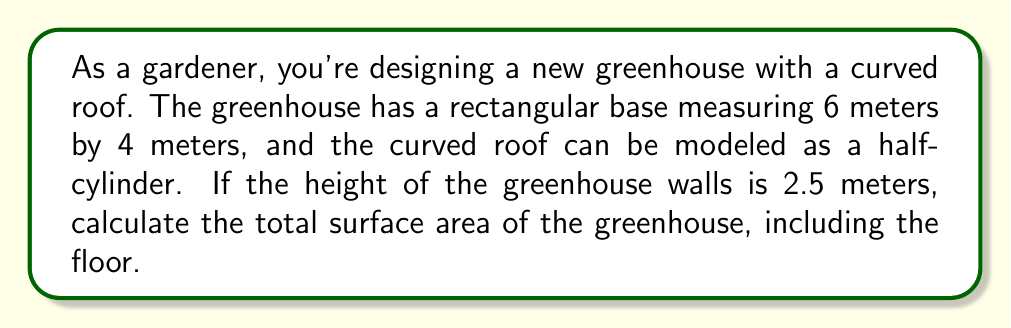Help me with this question. Let's approach this step-by-step:

1) First, we need to identify the components of the surface area:
   - Rectangular floor
   - Two rectangular end walls
   - Two rectangular side walls
   - Curved roof (half-cylinder)

2) Calculate the area of the floor:
   $A_{floor} = 6m \times 4m = 24m^2$

3) Calculate the area of the end walls (2 rectangles):
   $A_{ends} = 2 \times (4m \times 2.5m) = 20m^2$

4) Calculate the area of the side walls (2 rectangles):
   $A_{sides} = 2 \times (6m \times 2.5m) = 30m^2$

5) For the curved roof, we need to calculate the surface area of half a cylinder:
   - The length of the cylinder is 6m (length of the greenhouse)
   - The diameter of the cylinder is 4m (width of the greenhouse)
   - The formula for the surface area of a cylinder is $A = 2\pi r h + 2\pi r^2$
   - For half a cylinder, we use half of this: $A_{roof} = \frac{1}{2}(2\pi r h + 2\pi r^2) = \pi r h + \pi r^2$
   
   $A_{roof} = \pi \times 2m \times 6m + \pi \times (2m)^2$
   $A_{roof} = 12\pi m^2 + 4\pi m^2 = 16\pi m^2 \approx 50.27m^2$

6) Sum up all the areas:
   $A_{total} = A_{floor} + A_{ends} + A_{sides} + A_{roof}$
   $A_{total} = 24m^2 + 20m^2 + 30m^2 + 16\pi m^2$
   $A_{total} = 74m^2 + 16\pi m^2 \approx 124.27m^2$
Answer: $74 + 16\pi$ m² or approximately 124.27 m² 